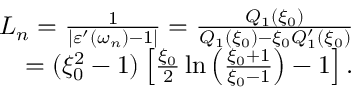<formula> <loc_0><loc_0><loc_500><loc_500>\begin{array} { r } { L _ { n } = \frac { 1 } { | \varepsilon ^ { \prime } ( \omega _ { n } ) - 1 | } = \frac { Q _ { 1 } ( \xi _ { 0 } ) } { Q _ { 1 } ( \xi _ { 0 } ) - \xi _ { 0 } Q _ { 1 } ^ { \prime } ( \xi _ { 0 } ) } } \\ { = ( \xi _ { 0 } ^ { 2 } - 1 ) \left [ \frac { \xi _ { 0 } } { 2 } \ln \left ( \frac { \xi _ { 0 } + 1 } { \xi _ { 0 } - 1 } \right ) - 1 \right ] . } \end{array}</formula> 